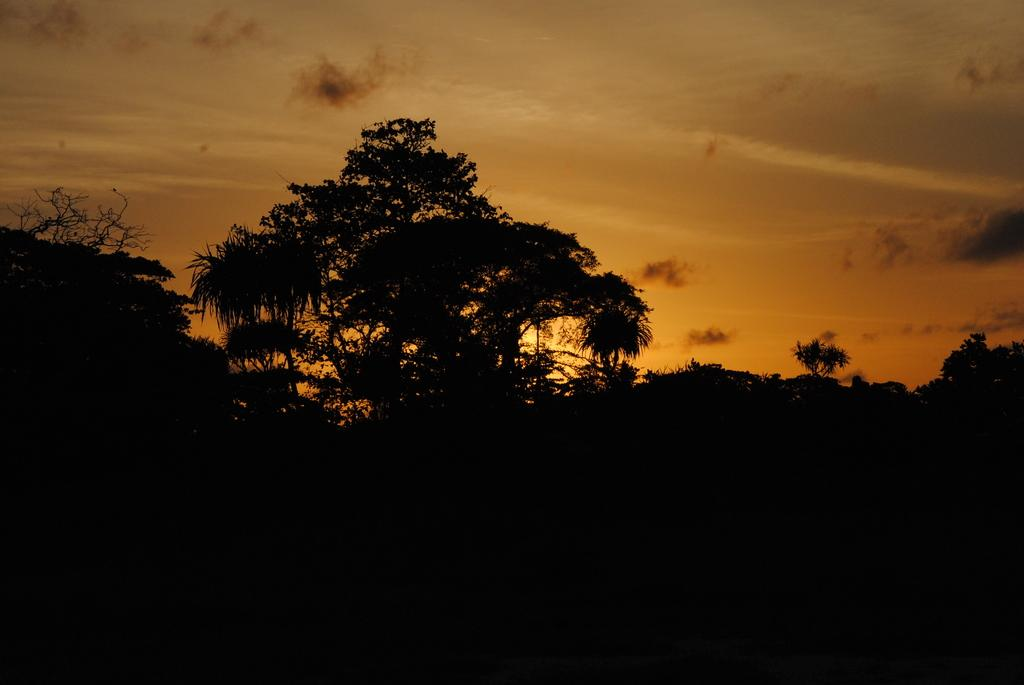What type of vegetation can be seen in the image? There are trees in the image. What part of the natural environment is visible in the image? The sky is visible in the image. How would you describe the lighting in the image? The image is dark. What type of rod can be seen in the image? There is no rod present in the image. Is there a recess in the image where people can gather? There is no recess or gathering area depicted in the image. What kind of music can be heard in the image? There is no music present in the image, as it is a visual representation. 